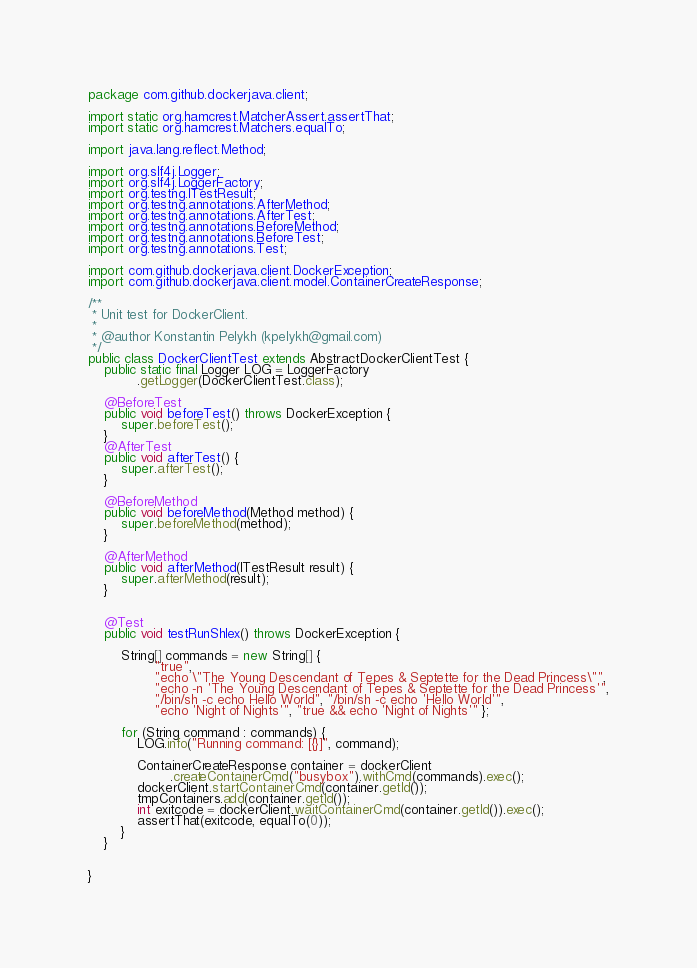<code> <loc_0><loc_0><loc_500><loc_500><_Java_>package com.github.dockerjava.client;

import static org.hamcrest.MatcherAssert.assertThat;
import static org.hamcrest.Matchers.equalTo;

import java.lang.reflect.Method;

import org.slf4j.Logger;
import org.slf4j.LoggerFactory;
import org.testng.ITestResult;
import org.testng.annotations.AfterMethod;
import org.testng.annotations.AfterTest;
import org.testng.annotations.BeforeMethod;
import org.testng.annotations.BeforeTest;
import org.testng.annotations.Test;

import com.github.dockerjava.client.DockerException;
import com.github.dockerjava.client.model.ContainerCreateResponse;

/**
 * Unit test for DockerClient.
 * 
 * @author Konstantin Pelykh (kpelykh@gmail.com)
 */
public class DockerClientTest extends AbstractDockerClientTest {
	public static final Logger LOG = LoggerFactory
			.getLogger(DockerClientTest.class);

	@BeforeTest
	public void beforeTest() throws DockerException {
		super.beforeTest();
	}
	@AfterTest
	public void afterTest() {
		super.afterTest();
	}

	@BeforeMethod
	public void beforeMethod(Method method) {
	    super.beforeMethod(method);
	}

	@AfterMethod
	public void afterMethod(ITestResult result) {
		super.afterMethod(result);
	}

	
	@Test
	public void testRunShlex() throws DockerException {

		String[] commands = new String[] {
				"true",
				"echo \"The Young Descendant of Tepes & Septette for the Dead Princess\"",
				"echo -n 'The Young Descendant of Tepes & Septette for the Dead Princess'",
				"/bin/sh -c echo Hello World", "/bin/sh -c echo 'Hello World'",
				"echo 'Night of Nights'", "true && echo 'Night of Nights'" };

		for (String command : commands) {
			LOG.info("Running command: [{}]", command);

			ContainerCreateResponse container = dockerClient
					.createContainerCmd("busybox").withCmd(commands).exec();
			dockerClient.startContainerCmd(container.getId());
			tmpContainers.add(container.getId());
			int exitcode = dockerClient.waitContainerCmd(container.getId()).exec();
			assertThat(exitcode, equalTo(0));
		}
	}
	
	
}</code> 